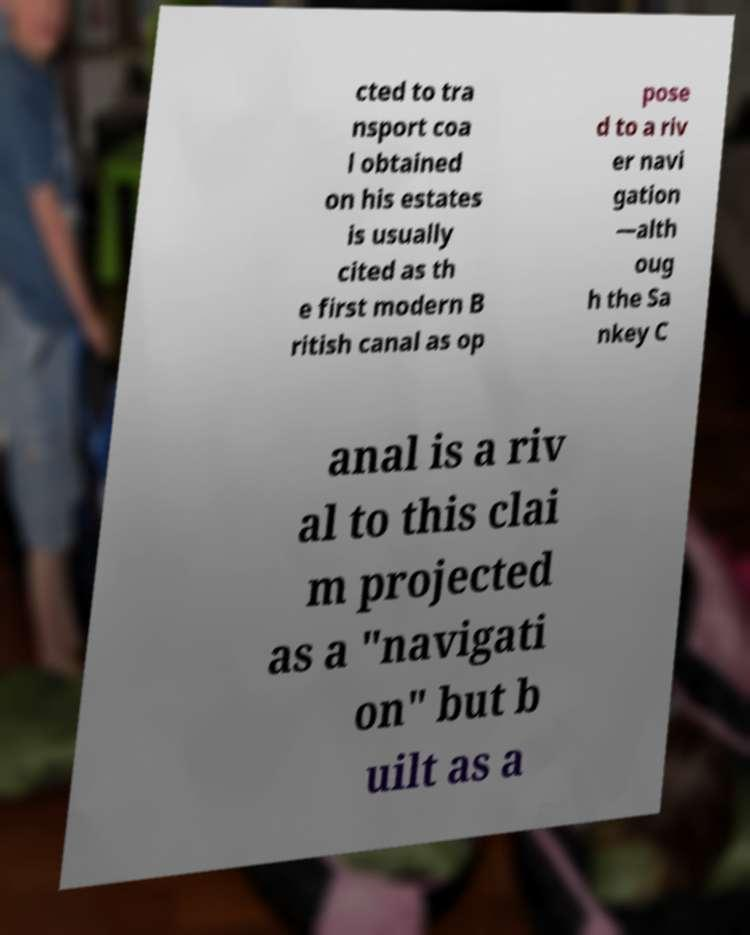Could you extract and type out the text from this image? cted to tra nsport coa l obtained on his estates is usually cited as th e first modern B ritish canal as op pose d to a riv er navi gation —alth oug h the Sa nkey C anal is a riv al to this clai m projected as a "navigati on" but b uilt as a 